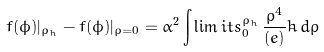Convert formula to latex. <formula><loc_0><loc_0><loc_500><loc_500>f ( \phi ) | _ { \rho _ { h } } - f ( \phi ) | _ { \rho = 0 } = \alpha ^ { 2 } \int \lim i t s _ { 0 } ^ { \rho _ { h } } \, \frac { \rho ^ { 4 } } { ( e ) } \dot { h } \, d \rho</formula> 